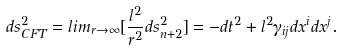Convert formula to latex. <formula><loc_0><loc_0><loc_500><loc_500>d s _ { C F T } ^ { 2 } = l i m _ { r \to \infty } [ \frac { l ^ { 2 } } { r ^ { 2 } } d s _ { n + 2 } ^ { 2 } ] = - d t ^ { 2 } + l ^ { 2 } \gamma _ { i j } d x ^ { i } d x ^ { j } .</formula> 